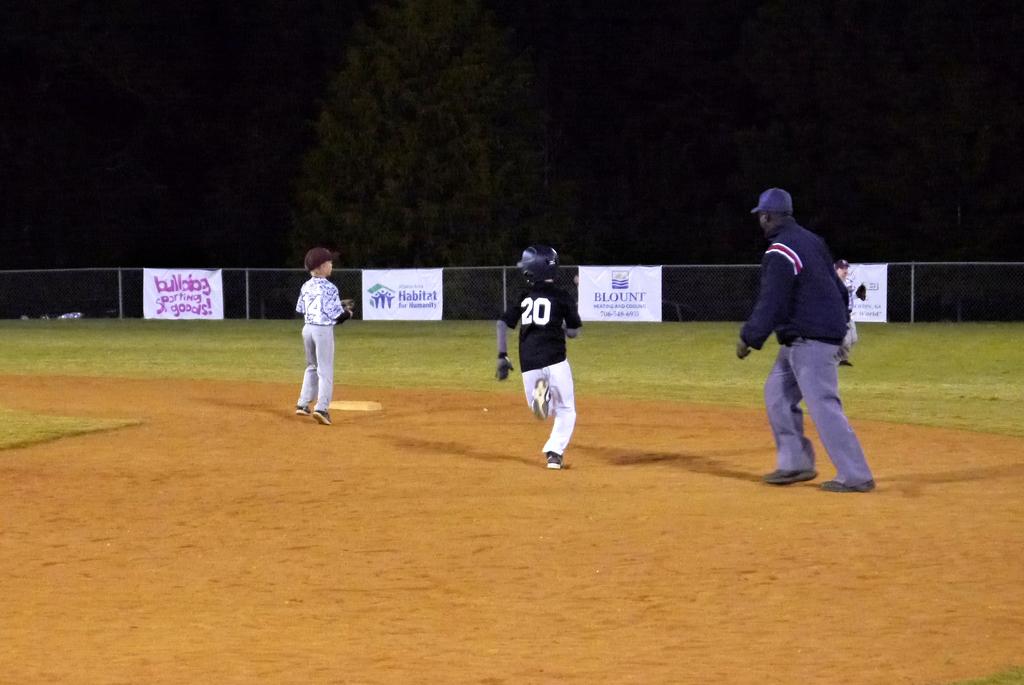What does the sign on the left side of the fence say?
Provide a short and direct response. Bulldog sporting goods. Whats number is on the black shirt?
Your answer should be compact. 20. 